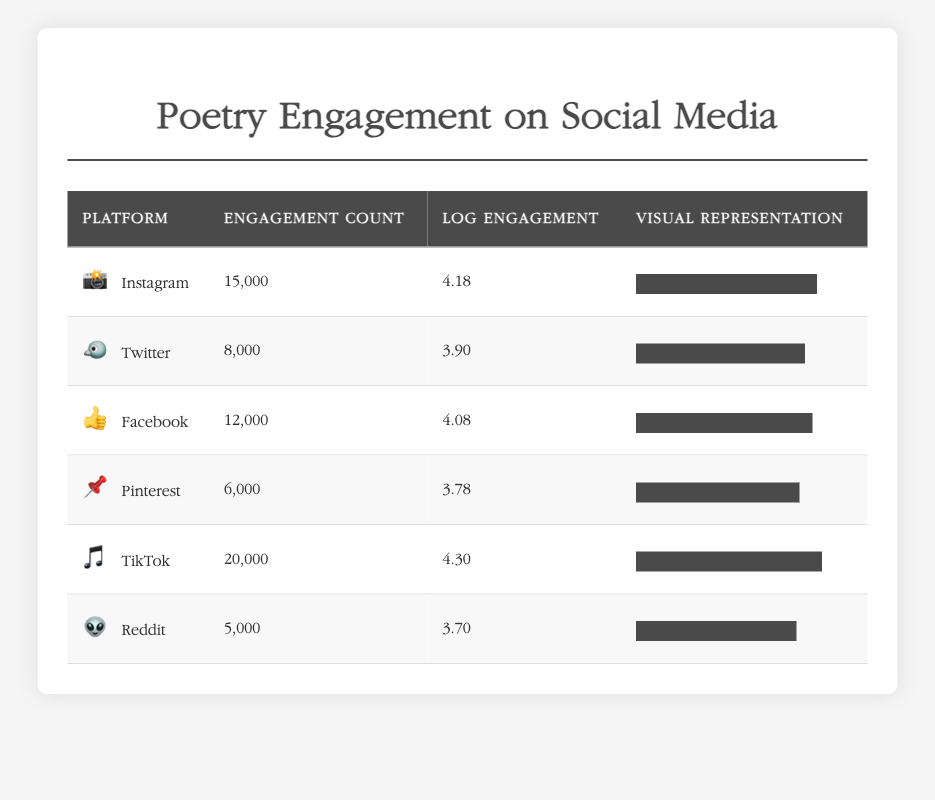What is the engagement count for TikTok? The table lists engagement counts for each platform. Looking at the row for TikTok, the engagement count is presented as 20,000.
Answer: 20,000 Which platform has the highest logarithmic engagement value? The logarithmic engagement values for each platform are listed in the table. By checking the values, TikTok has the highest value at 4.30, compared to others.
Answer: TikTok What is the average engagement count across all platforms? To find the average, sum all engagement counts: 15000 + 8000 + 12000 + 6000 + 20000 + 5000 = 67500. There are 6 platforms, so the average is 67500/6 = 11250.
Answer: 11,250 Is the engagement count for Instagram greater than that of Facebook? The engagement counts for Instagram and Facebook are compared directly: Instagram has 15,000 and Facebook has 12,000. Since 15,000 is greater than 12,000, the answer is yes.
Answer: Yes What is the difference in engagement counts between the platforms with the highest and lowest engagement? The highest engagement count is from TikTok at 20,000 and the lowest is from Reddit at 5,000. To find the difference, subtract: 20,000 - 5,000 = 15,000.
Answer: 15,000 Which platform has a logarithmic engagement value closest to 4.0? The logarithmic values listed are: Instagram (4.18), Twitter (3.90), Facebook (4.08), Pinterest (3.78), TikTok (4.30), and Reddit (3.70). Facebook has a value of 4.08, which is the closest to 4.0.
Answer: Facebook How many platforms have an engagement count higher than 10,000? Reviewing the engagement counts, those higher than 10,000 are Instagram (15,000), Facebook (12,000), and TikTok (20,000). There are three platforms in total that meet this criteria.
Answer: 3 What is the percentage representation of engagement for Twitter? The engagement count for Twitter is 8,000. The maximum engagement count is 20,000 (from TikTok). To find the percentage: (8000/20000) * 100 = 40%.
Answer: 40% Which platform shows the least amount of engagement based on both engagement count and logarithmic value? By checking the engagement counts, Reddit has the lowest at 5,000 and its logarithmic value is also the lowest at 3.70. Thus, Reddit shows the least engagement overall.
Answer: Reddit 